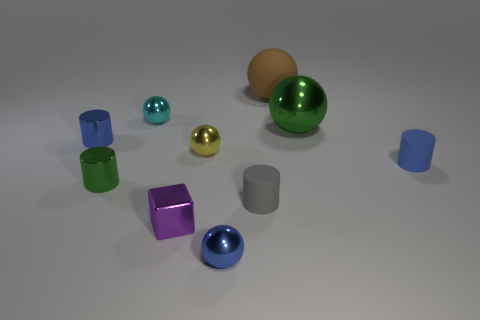What could be the context or purpose of this arrangement of objects? This arrangement of objects might represent a deliberately staged composition for a study in shape and color. Each object's unique geometry in correlation with the varied hues could be showcasing principles of visual design, such as contrast, balance, and form. Alternatively, it could be a simple display for an educational purpose, allowing viewers to distinguish between shapes like spheres, cylinders, and cubes. Could these objects have practical uses? In a real-world setting, these objects might serve as models for design prototypes or as educational aids in a classroom to teach geometry. However, given their context here, they most likely serve a purely illustrative function, perhaps for a computer graphics demonstration or artistic composition. Their sizes and simplicity suggest their primary function is to inform or display rather than for any practical tool use. 